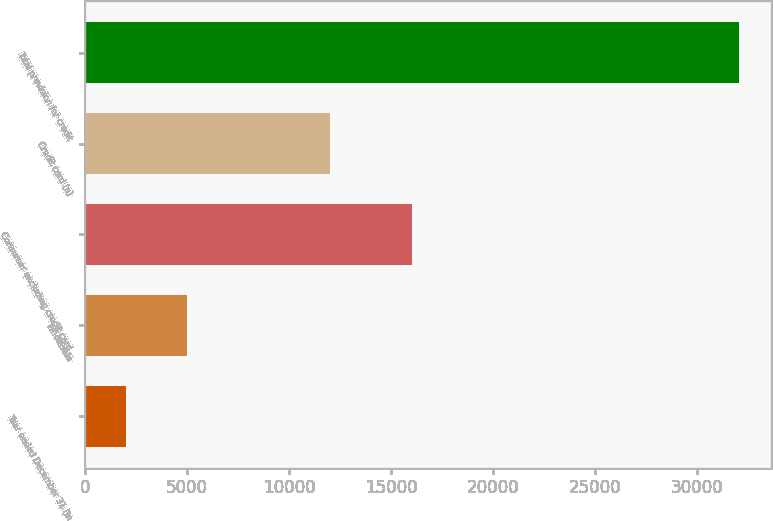Convert chart. <chart><loc_0><loc_0><loc_500><loc_500><bar_chart><fcel>Year ended December 31 (in<fcel>Wholesale<fcel>Consumer excluding credit card<fcel>Credit card (a)<fcel>Total provision for credit<nl><fcel>2009<fcel>5009.6<fcel>16022<fcel>12019<fcel>32015<nl></chart> 